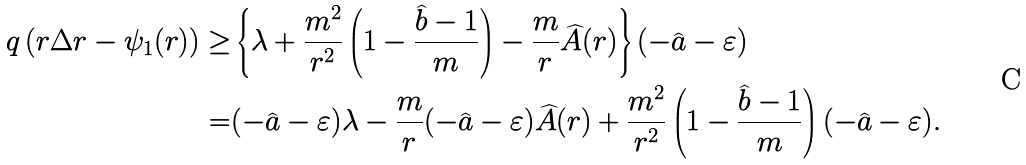<formula> <loc_0><loc_0><loc_500><loc_500>q \left ( r \Delta r - \psi _ { 1 } ( r ) \right ) \geq & \left \{ \lambda + \frac { m ^ { 2 } } { r ^ { 2 } } \left ( 1 - \frac { \widehat { b } - 1 } { m } \right ) - \frac { m } { r } \widehat { A } ( r ) \right \} ( - \widehat { a } - \varepsilon ) \\ = & ( - \widehat { a } - \varepsilon ) \lambda - \frac { m } { r } ( - \widehat { a } - \varepsilon ) \widehat { A } ( r ) + \frac { m ^ { 2 } } { r ^ { 2 } } \left ( 1 - \frac { \widehat { b } - 1 } { m } \right ) ( - \widehat { a } - \varepsilon ) .</formula> 